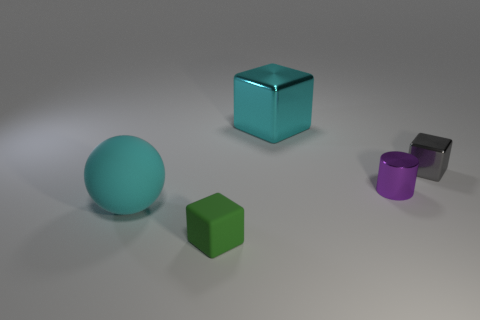What materials might the objects be made of based on their appearance? The objects appear to have a matte and slightly reflective surface which suggests they might be made of metal or a similar material with a metallic finish. 